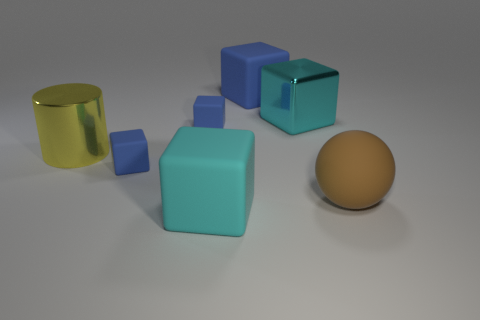What does the arrangement of objects convey? The objects are randomly scattered, which could imply a lack of organization. However, this randomness may suggest the concept of diversity or individuality among similar shapes, as there is no discernible pattern to their placement. Could this image be used to teach any concepts? Absolutely. This image could be used to teach various concepts such as geometry, by examining the shapes; material properties, by discussing textures and reflections; and color theory, by exploring the color palette used. 